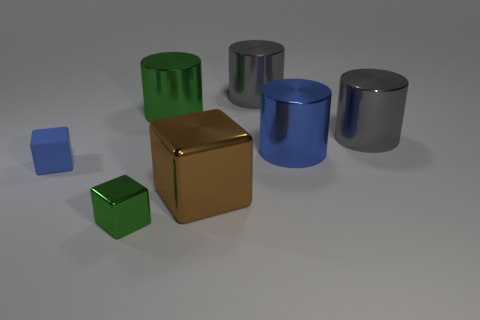Subtract all big blocks. How many blocks are left? 2 Subtract all blue cylinders. How many cylinders are left? 3 Subtract all cylinders. How many objects are left? 3 Subtract all blue cubes. How many gray cylinders are left? 2 Add 3 large metallic things. How many objects exist? 10 Add 4 big gray cylinders. How many big gray cylinders are left? 6 Add 7 blue rubber objects. How many blue rubber objects exist? 8 Subtract 0 brown spheres. How many objects are left? 7 Subtract 1 blocks. How many blocks are left? 2 Subtract all blue cylinders. Subtract all cyan cubes. How many cylinders are left? 3 